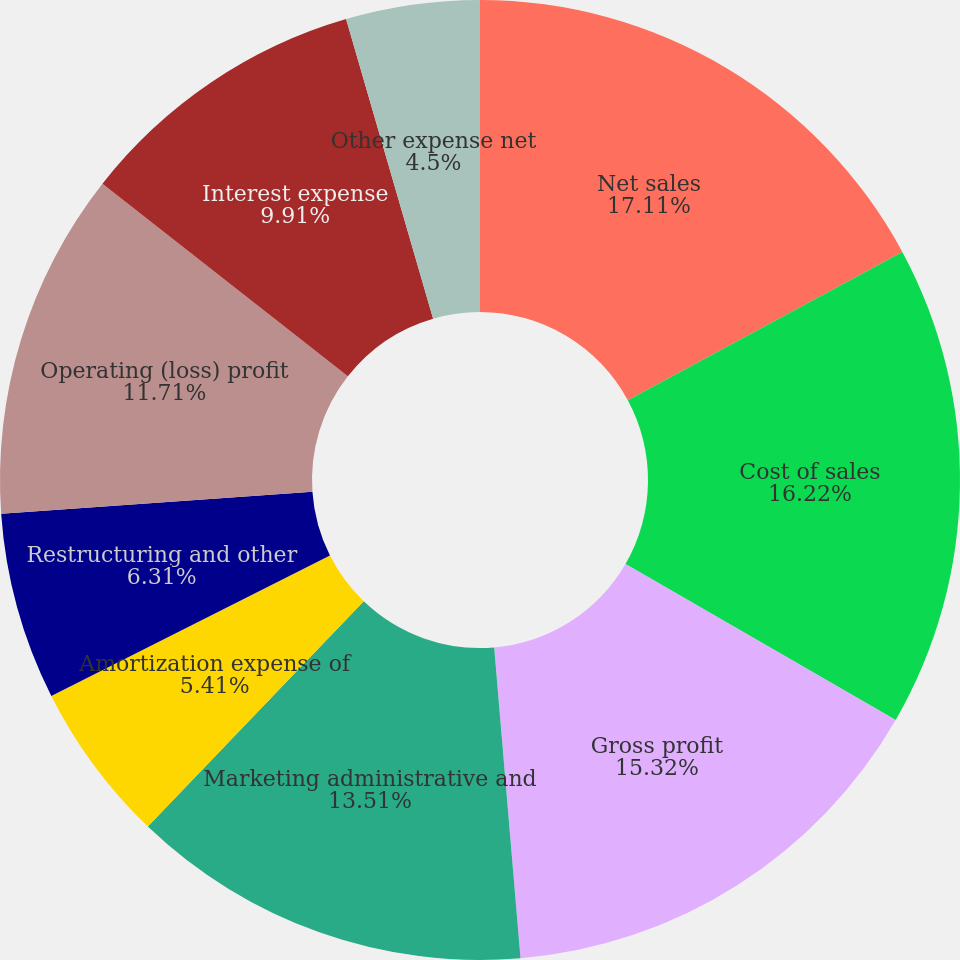Convert chart to OTSL. <chart><loc_0><loc_0><loc_500><loc_500><pie_chart><fcel>Net sales<fcel>Cost of sales<fcel>Gross profit<fcel>Marketing administrative and<fcel>Amortization expense of<fcel>Restructuring and other<fcel>Operating (loss) profit<fcel>Interest expense<fcel>Foreign currency exchange<fcel>Other expense net<nl><fcel>17.12%<fcel>16.22%<fcel>15.32%<fcel>13.51%<fcel>5.41%<fcel>6.31%<fcel>11.71%<fcel>9.91%<fcel>0.0%<fcel>4.5%<nl></chart> 